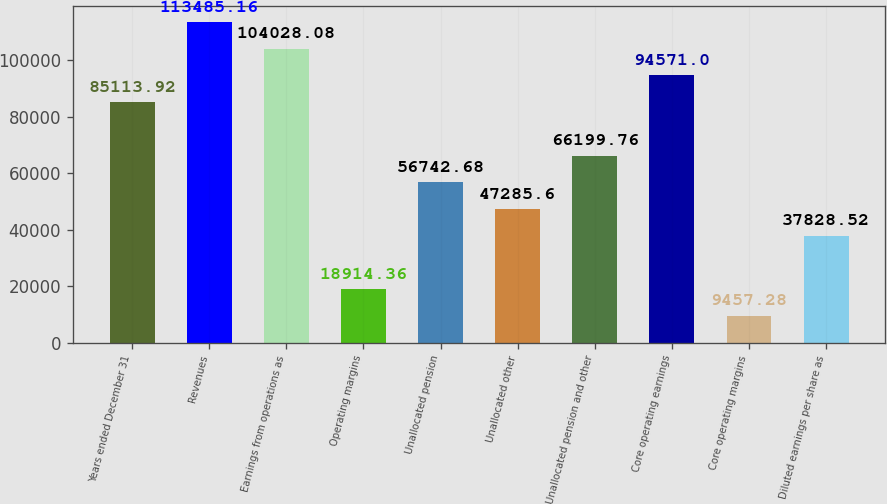Convert chart to OTSL. <chart><loc_0><loc_0><loc_500><loc_500><bar_chart><fcel>Years ended December 31<fcel>Revenues<fcel>Earnings from operations as<fcel>Operating margins<fcel>Unallocated pension<fcel>Unallocated other<fcel>Unallocated pension and other<fcel>Core operating earnings<fcel>Core operating margins<fcel>Diluted earnings per share as<nl><fcel>85113.9<fcel>113485<fcel>104028<fcel>18914.4<fcel>56742.7<fcel>47285.6<fcel>66199.8<fcel>94571<fcel>9457.28<fcel>37828.5<nl></chart> 